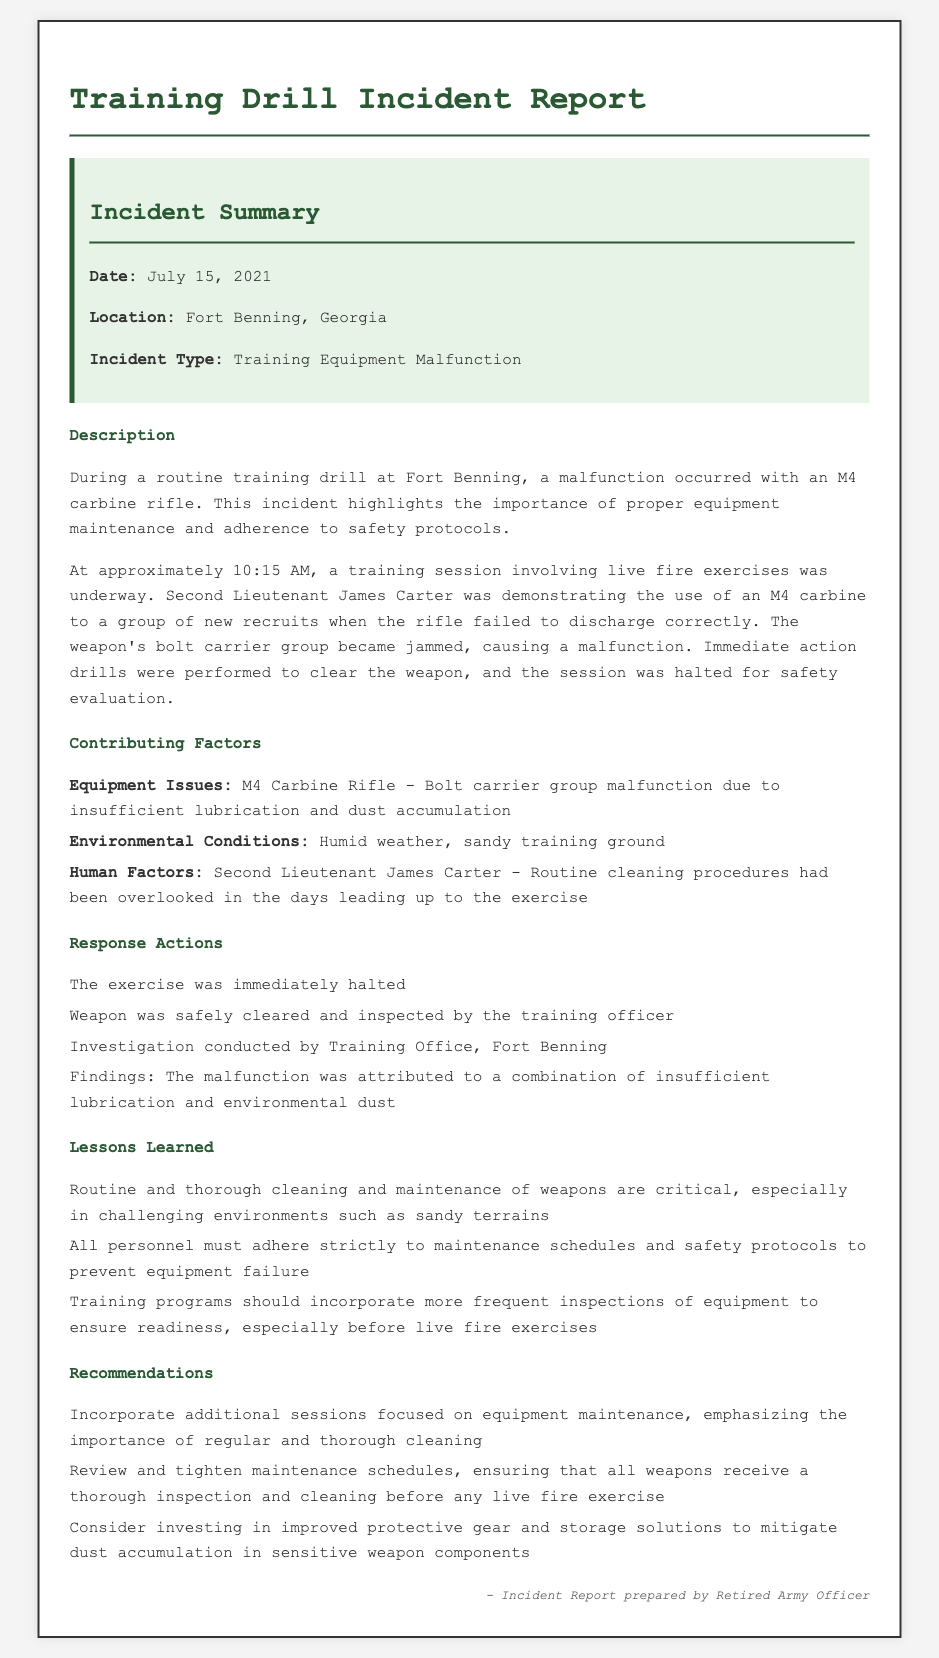What was the date of the incident? The date of the incident is mentioned in the incident summary.
Answer: July 15, 2021 Where did the incident occur? The location of the incident is specified in the incident summary.
Answer: Fort Benning, Georgia What type of incident occurred? The incident type can be found in the incident summary.
Answer: Training Equipment Malfunction Who was involved in the incident? The report mentions the key individual involved during the incident.
Answer: Second Lieutenant James Carter What malfunction occurred during the training drill? The description section highlights the specific issue encountered during the drill.
Answer: Bolt carrier group malfunction What were the environmental conditions during the incident? The contributing factors section outlines the environmental conditions affecting the training.
Answer: Humid weather, sandy training ground What was a key lesson learned from the incident? The lessons learned section identifies critical takeaways from the event.
Answer: Routine and thorough cleaning and maintenance of weapons are critical What action was taken after the malfunction was discovered? The response actions section lists actions taken following the incident.
Answer: The exercise was immediately halted What recommendation was made to prevent similar incidents? Recommendations offered in the document provide suggestions for future preventative measures.
Answer: Incorporate additional sessions focused on equipment maintenance 